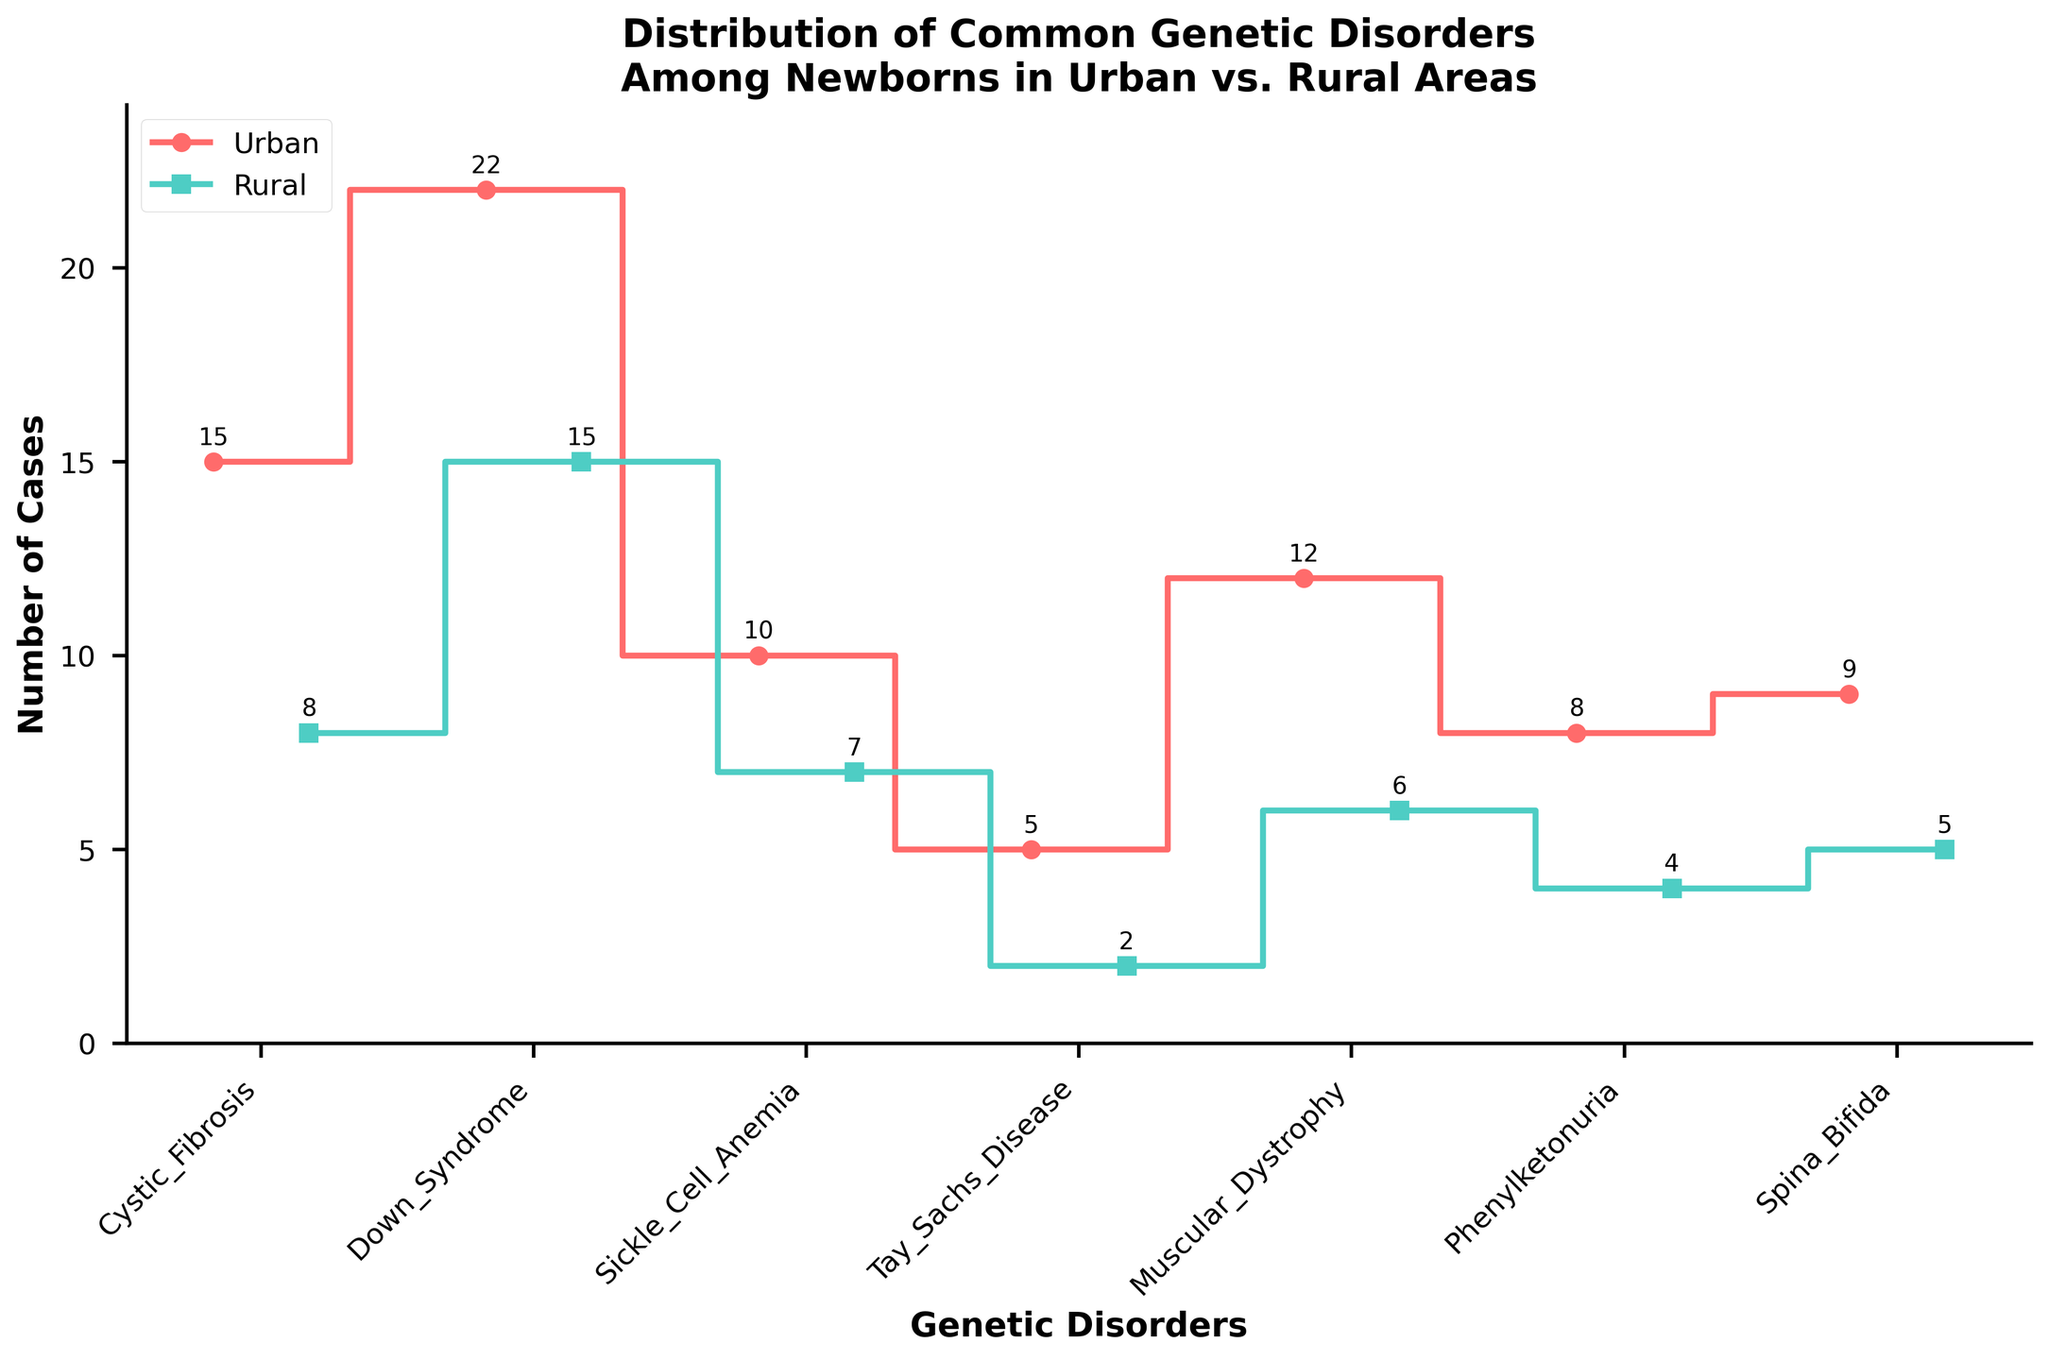What is the title of the plot? The title of the plot is located at the top and usually provides an overview or summary of what the graph represents. In this case, it is clearly stated at the top of the figure.
Answer: Distribution of Common Genetic Disorders Among Newborns in Urban vs. Rural Areas How many genetic disorders are displayed on the x-axis? The number of disorders is indicated by the tick marks and labels along the x-axis. By counting them, we can determine the total.
Answer: 7 Which area has the highest number of Down Syndrome cases? By comparing the position of the data points for Down Syndrome on the plot, we can see which area (Urban or Rural) has a higher number of cases. The red line (Urban) reaches higher than the blue line (Rural) for Down Syndrome.
Answer: Urban What is the difference in Cystic Fibrosis cases between urban and rural areas? To find the difference, subtract the number of rural cases from the number of urban cases for Cystic Fibrosis. The values are given directly next to the markers for Cystic Fibrosis.
Answer: 7 Which genetic disorder has the smallest number of cases in rural areas? Observing the plot, we identify the genetic disorder by looking for the lowest green marker, which represents rural cases. The lowest point corresponds to Tay-Sachs Disease.
Answer: Tay-Sachs Disease What is the total number of cases for Muscular Dystrophy in both urban and rural areas combined? Add the number of urban and rural cases for Muscular Dystrophy. The bars show 12 cases for urban areas and 6 cases for rural areas.
Answer: 18 Compare the number of urban cases of Phenylketonuria to rural cases. Which one is greater and by how much? Check the values associated with Phenylketonuria for both urban and rural areas. Calculate the difference by subtracting the rural value from the urban value.
Answer: Urban by 4 Among the genetic disorders, which disorder shows an equal number of cases in both urban and rural areas? Look for a disorder in the plot where the steps for urban (red) and rural (green) intersect at the same height. There appears to be no disorder with equal values in the given plot.
Answer: None What is the second highest number of cases in either urban or rural areas? Identify the highest number first, and then look for the next highest number, which involves comparing all the data points and ignoring the highest one. Down Syndrome in urban areas has the highest (22), so next is 15, seen in rural areas for Down Syndrome.
Answer: 15 